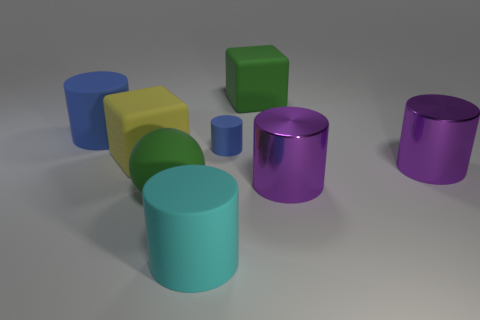Are there any objects that have the same color as the small cylinder?
Offer a very short reply. Yes. Are there more large matte blocks that are in front of the yellow rubber block than big green objects?
Ensure brevity in your answer.  No. There is a tiny rubber thing that is the same shape as the large cyan matte object; what color is it?
Your answer should be compact. Blue. What is the shape of the green thing that is behind the big blue rubber cylinder?
Provide a short and direct response. Cube. Are there any matte things right of the small blue rubber object?
Provide a short and direct response. Yes. What color is the sphere that is made of the same material as the tiny cylinder?
Your response must be concise. Green. Does the small matte thing right of the green sphere have the same color as the cylinder that is on the left side of the cyan cylinder?
Offer a very short reply. Yes. What number of cubes are small blue rubber objects or small red rubber objects?
Your answer should be very brief. 0. Are there the same number of green things to the left of the tiny cylinder and big gray cylinders?
Provide a succinct answer. No. There is a big block that is the same color as the large matte sphere; what is its material?
Provide a short and direct response. Rubber. 